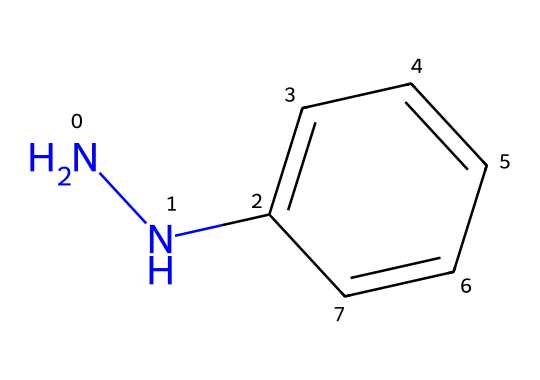What is the molecular formula of phenylhydrazine? The molecular formula can be determined by counting the number of each type of atom present in the chemical structure, which shows 2 nitrogen (N) atoms, 6 carbon (C) atoms, and 8 hydrogen (H) atoms. Thus, the molecular formula is C6H8N2.
Answer: C6H8N2 How many nitrogen atoms are present in the structure? By examining the SMILES representation, we can see that there are two occurrences of the nitrogen symbol "N" in the structure, indicating that there are two nitrogen atoms present.
Answer: 2 What functional group is present in phenylhydrazine? The presence of the nitrogen atoms bonded to the benzene ring characterizes this compound as having an amine functional group. Specifically, the nitrogen directly bonded to carbon suggests a primary amine connected with hydrazine.
Answer: amine How does the structure relate to its usage in fabric dyes? The aromatic ring (benzene) along with the hydrazine part of the molecule allows for complex interactions with fabric fibers, making it suitable for creating vibrant dye colors. This structure facilitates dye-binding due to its electron-rich nature from the aromatic system contributing to color properties.
Answer: dye-binding What type of chemical is phenylhydrazine classified as? Phenylhydrazine is classified as a hydrazine derivative due to the presence of the -NH-NH2 group and the benzene ring, which fall under the category of organic hydrazines that have special properties such as reducing agents.
Answer: hydrazine 